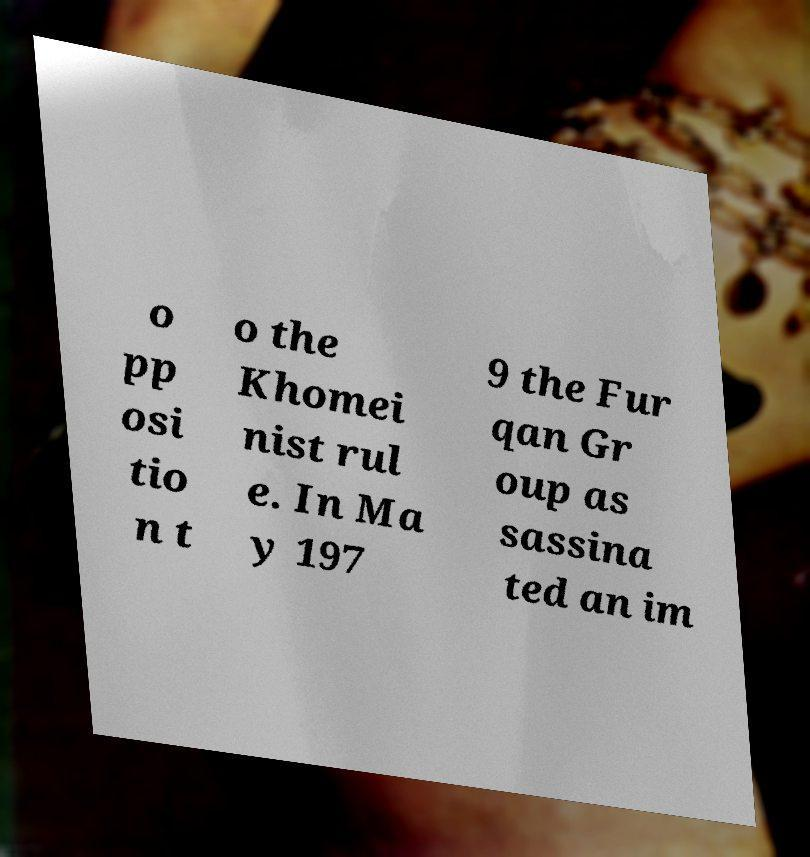There's text embedded in this image that I need extracted. Can you transcribe it verbatim? o pp osi tio n t o the Khomei nist rul e. In Ma y 197 9 the Fur qan Gr oup as sassina ted an im 